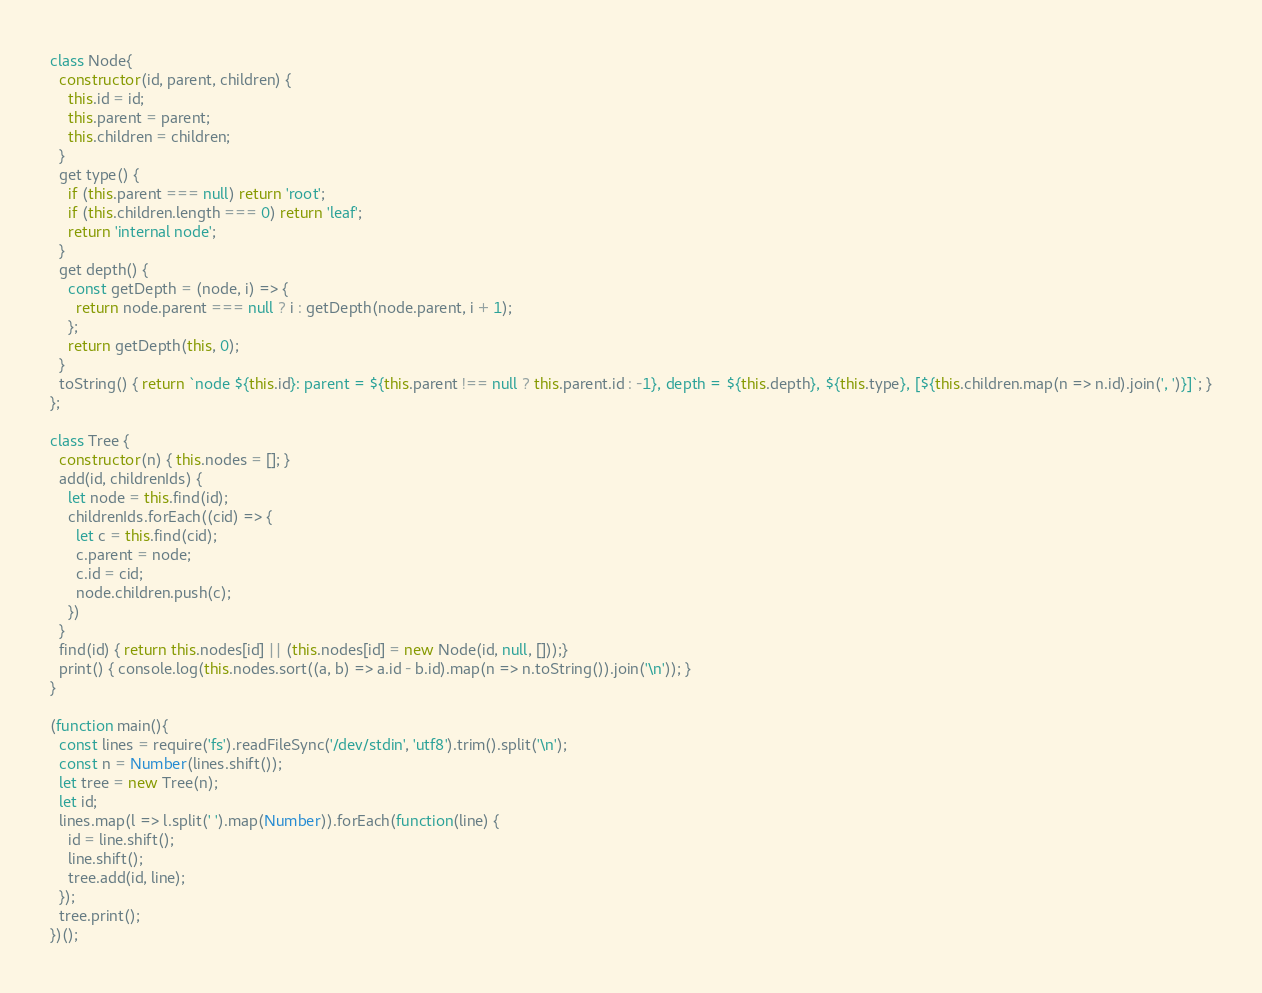Convert code to text. <code><loc_0><loc_0><loc_500><loc_500><_JavaScript_>class Node{
  constructor(id, parent, children) {
    this.id = id;
    this.parent = parent;
    this.children = children;
  }
  get type() {
    if (this.parent === null) return 'root';
    if (this.children.length === 0) return 'leaf';
    return 'internal node';
  }
  get depth() {
    const getDepth = (node, i) => {
      return node.parent === null ? i : getDepth(node.parent, i + 1);
    };
    return getDepth(this, 0);
  }
  toString() { return `node ${this.id}: parent = ${this.parent !== null ? this.parent.id : -1}, depth = ${this.depth}, ${this.type}, [${this.children.map(n => n.id).join(', ')}]`; }
};

class Tree {
  constructor(n) { this.nodes = []; }
  add(id, childrenIds) {
    let node = this.find(id);
    childrenIds.forEach((cid) => {
      let c = this.find(cid);
      c.parent = node;
      c.id = cid;
      node.children.push(c);
    })
  }
  find(id) { return this.nodes[id] || (this.nodes[id] = new Node(id, null, []));}
  print() { console.log(this.nodes.sort((a, b) => a.id - b.id).map(n => n.toString()).join('\n')); }
}

(function main(){
  const lines = require('fs').readFileSync('/dev/stdin', 'utf8').trim().split('\n');
  const n = Number(lines.shift());
  let tree = new Tree(n);
  let id;
  lines.map(l => l.split(' ').map(Number)).forEach(function(line) {
    id = line.shift();
    line.shift();
    tree.add(id, line);
  });
  tree.print();
})();

</code> 